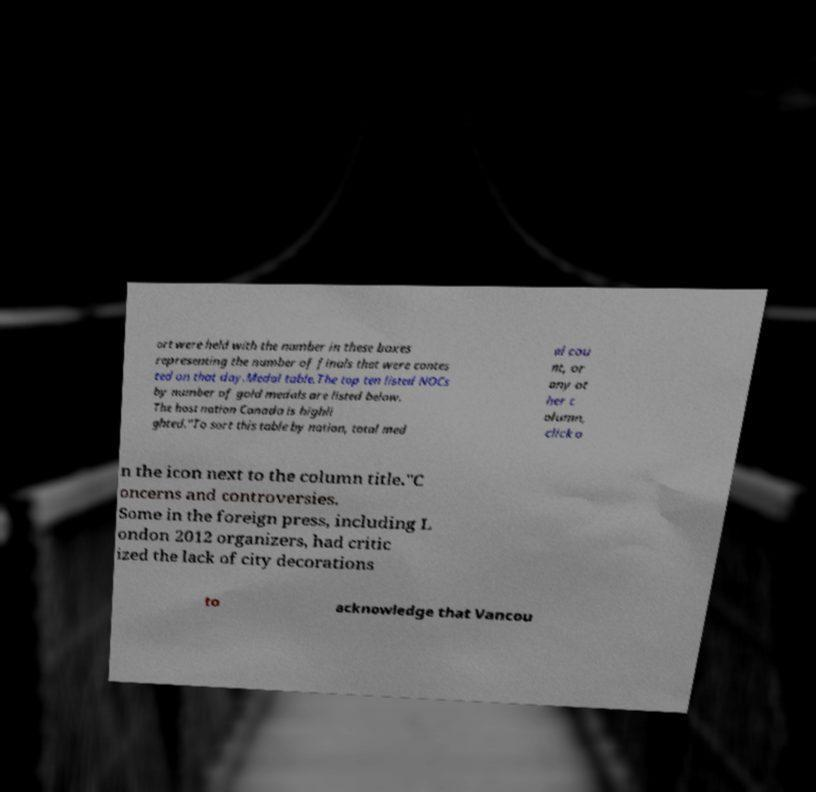For documentation purposes, I need the text within this image transcribed. Could you provide that? ort were held with the number in these boxes representing the number of finals that were contes ted on that day.Medal table.The top ten listed NOCs by number of gold medals are listed below. The host nation Canada is highli ghted."To sort this table by nation, total med al cou nt, or any ot her c olumn, click o n the icon next to the column title."C oncerns and controversies. Some in the foreign press, including L ondon 2012 organizers, had critic ized the lack of city decorations to acknowledge that Vancou 